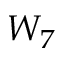<formula> <loc_0><loc_0><loc_500><loc_500>W _ { 7 }</formula> 